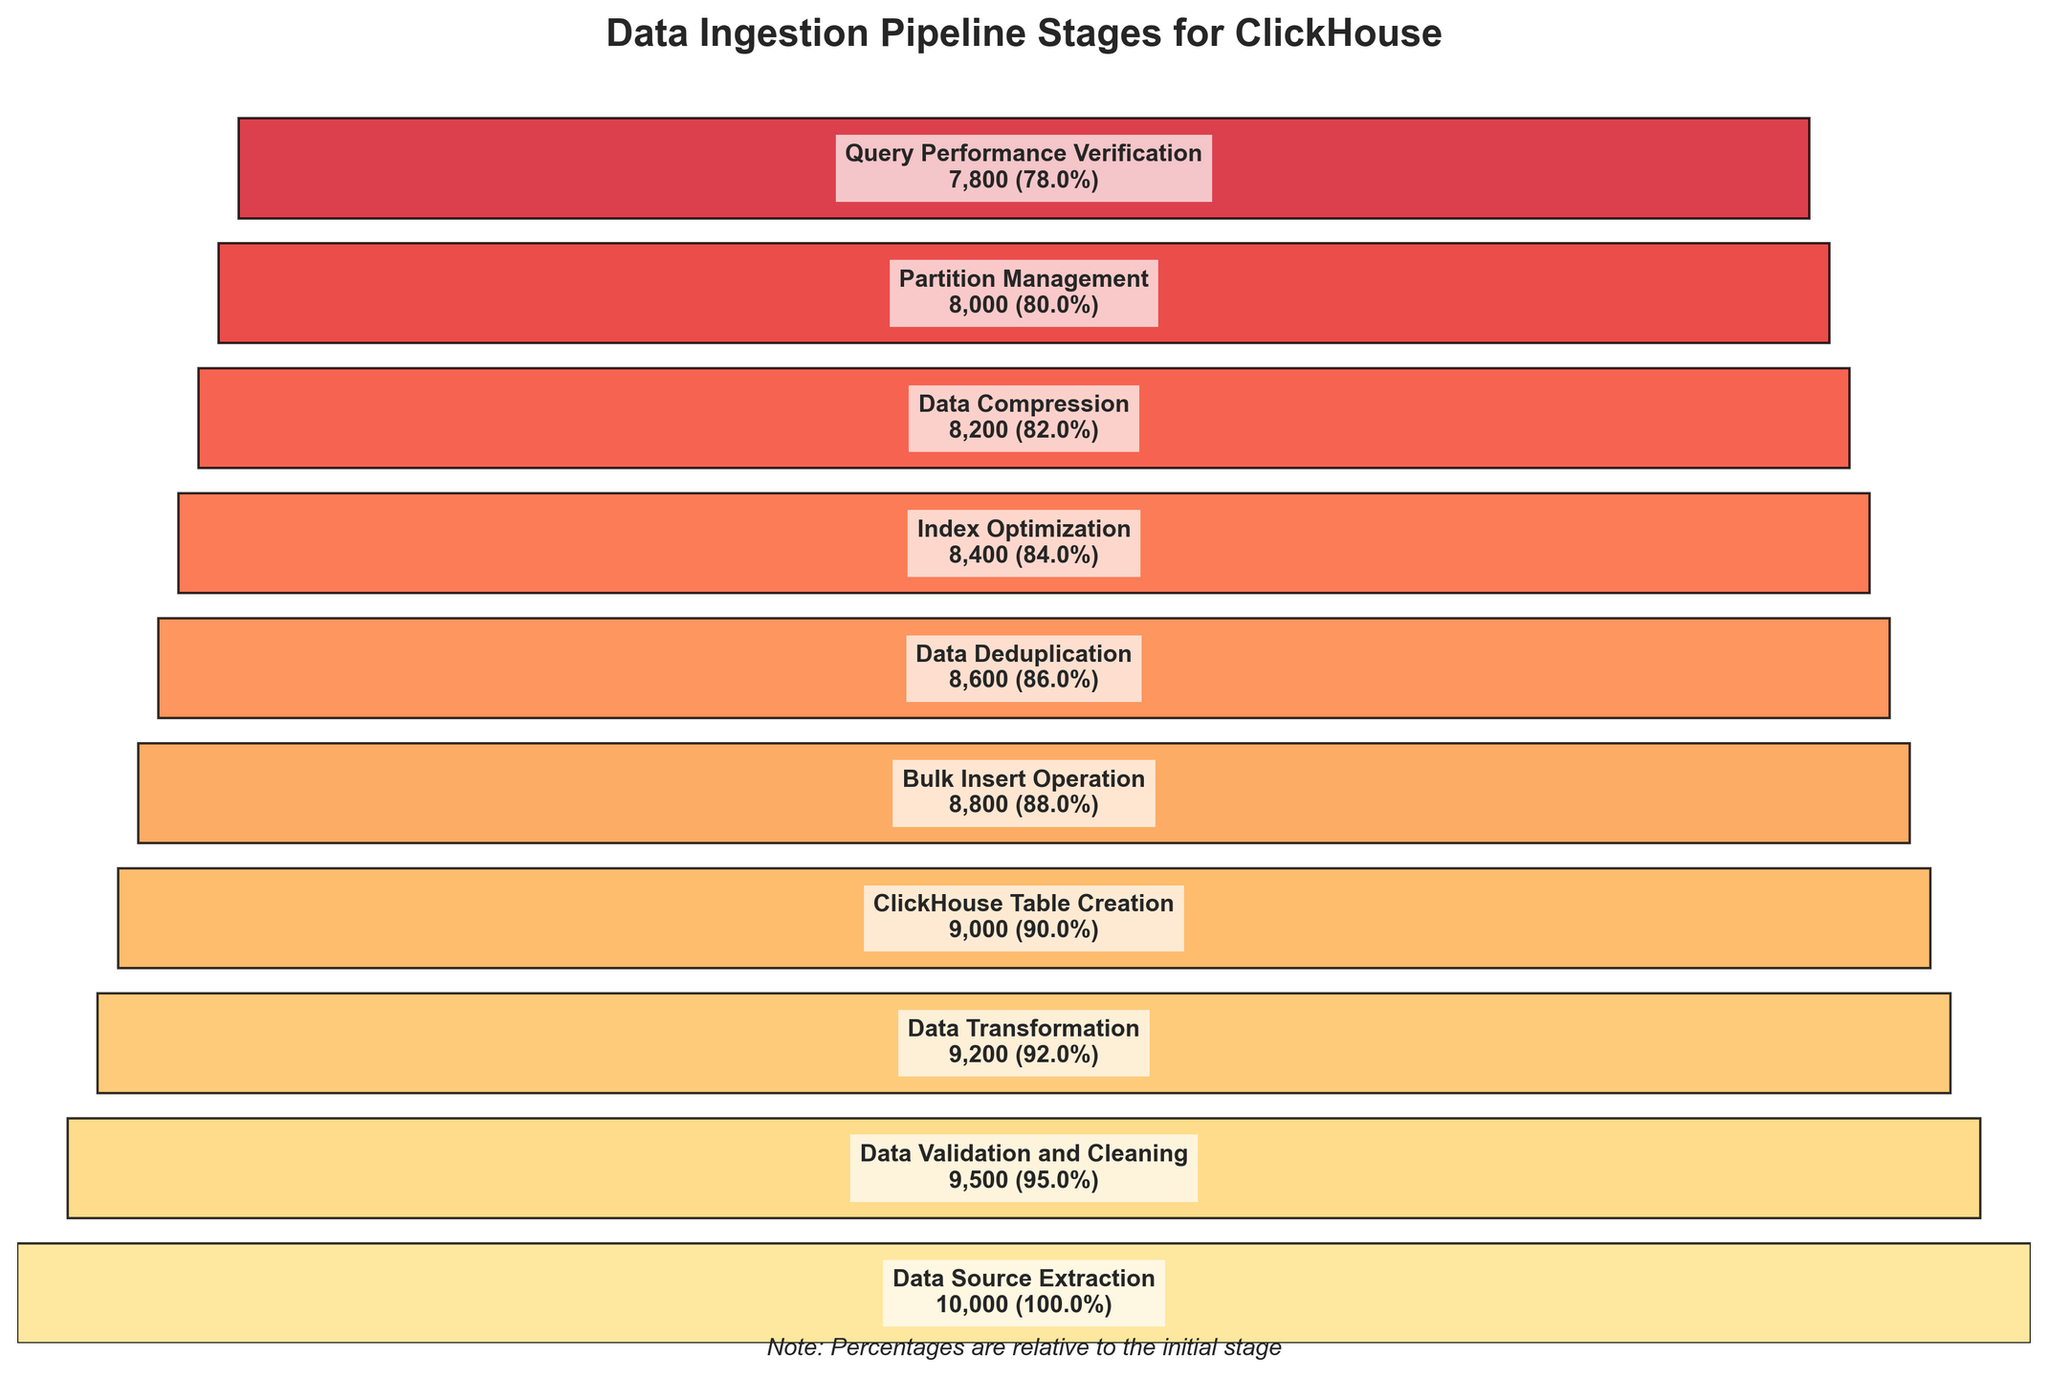What is the title of the funnel chart? The title of the funnel chart is typically found at the top and provides a summary of the chart's content. In this case, it reads, "Data Ingestion Pipeline Stages for ClickHouse".
Answer: Data Ingestion Pipeline Stages for ClickHouse How many stages are depicted in the funnel chart? To determine the number of stages, count the unique stages listed alongside their respective counts in the chart. There are 10 rows of data, each representing a stage.
Answer: 10 Which stage has the highest count? The stage with the highest count is the first entry in the funnel since the counts decrease sequentially from top to bottom. The first stage listed is "Data Source Extraction" with a count of 10,000.
Answer: Data Source Extraction What is the percentage drop from 'Data Validation and Cleaning' to 'ClickHouse Table Creation'? To find the percentage drop between two stages, compute the individual percentages relative to the initial stage and then find their difference. From 'Data Validation and Cleaning' at 95% to 'ClickHouse Table Creation' at 90%, the drop is 95% - 90%.
Answer: 5% Which stage has the smallest count? The smallest count corresponds to the final stage of the funnel. According to the data, 'Query Performance Verification' is the last stage with a count of 7,800.
Answer: Query Performance Verification What is the total count lost from 'Data Source Extraction' to 'Query Performance Verification'? Calculate the total count lost by subtracting the final stage's count from the initial stage's count. Therefore, the count is 10,000 - 7,800.
Answer: 2,200 What percentage of data makes it through to 'Data Deduplication'? To compute the percentage, take the count for 'Data Deduplication' and divide it by the initial stage's count, then multiply by 100. So, (8600 / 10,000) * 100.
Answer: 86% In terms of percentages, which stage transition has the highest data retention rate? The highest retention rate occurs where the percentage loss is smallest. Compute the percentage loss between consecutive stages and identify the smallest loss. From 'ClickHouse Table Creation' to 'Bulk Insert Operation', the loss is only (90% - 88%) = 2%. Therefore, this transition has the highest retention rate.
Answer: ClickHouse Table Creation to Bulk Insert Operation How many stages are below 85% of the initial data count? List out the stages and their percentages relative to the initial data count. Stages with percentages below 85% are Index Optimization (84%), Data Compression (82%), Partition Management (80%), and Query Performance Verification (78%). There are 4 such stages.
Answer: 4 